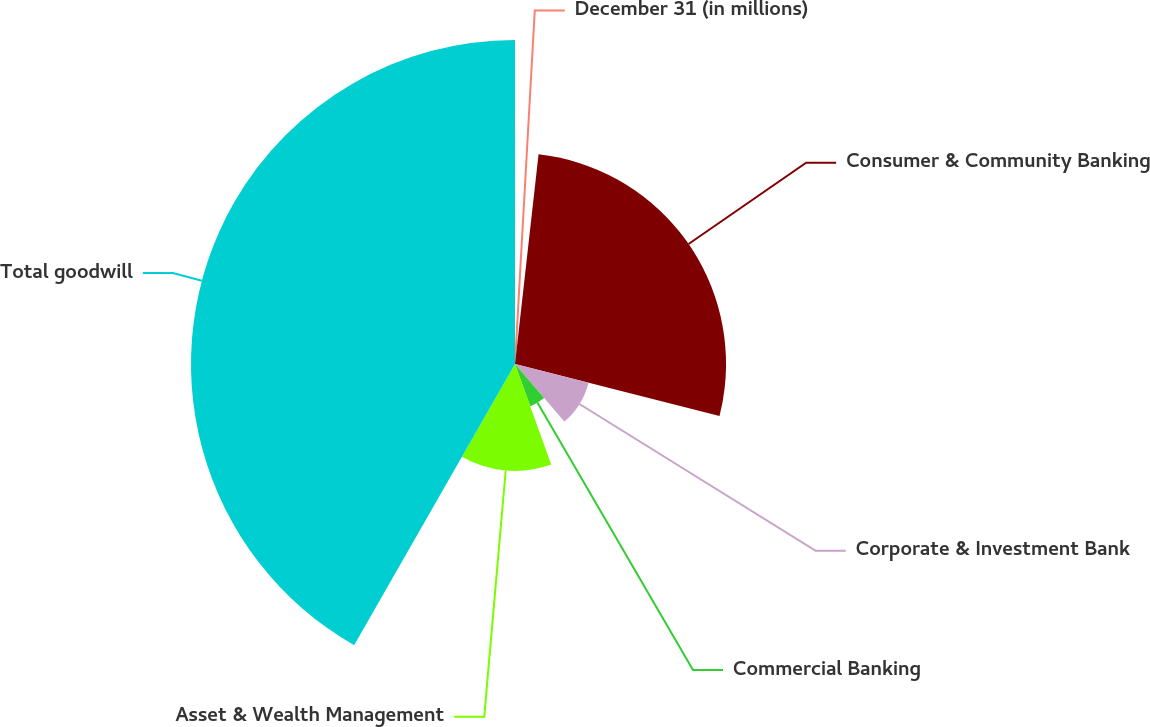Convert chart to OTSL. <chart><loc_0><loc_0><loc_500><loc_500><pie_chart><fcel>December 31 (in millions)<fcel>Consumer & Community Banking<fcel>Corporate & Investment Bank<fcel>Commercial Banking<fcel>Asset & Wealth Management<fcel>Total goodwill<nl><fcel>1.78%<fcel>27.18%<fcel>9.77%<fcel>5.77%<fcel>13.77%<fcel>41.73%<nl></chart> 